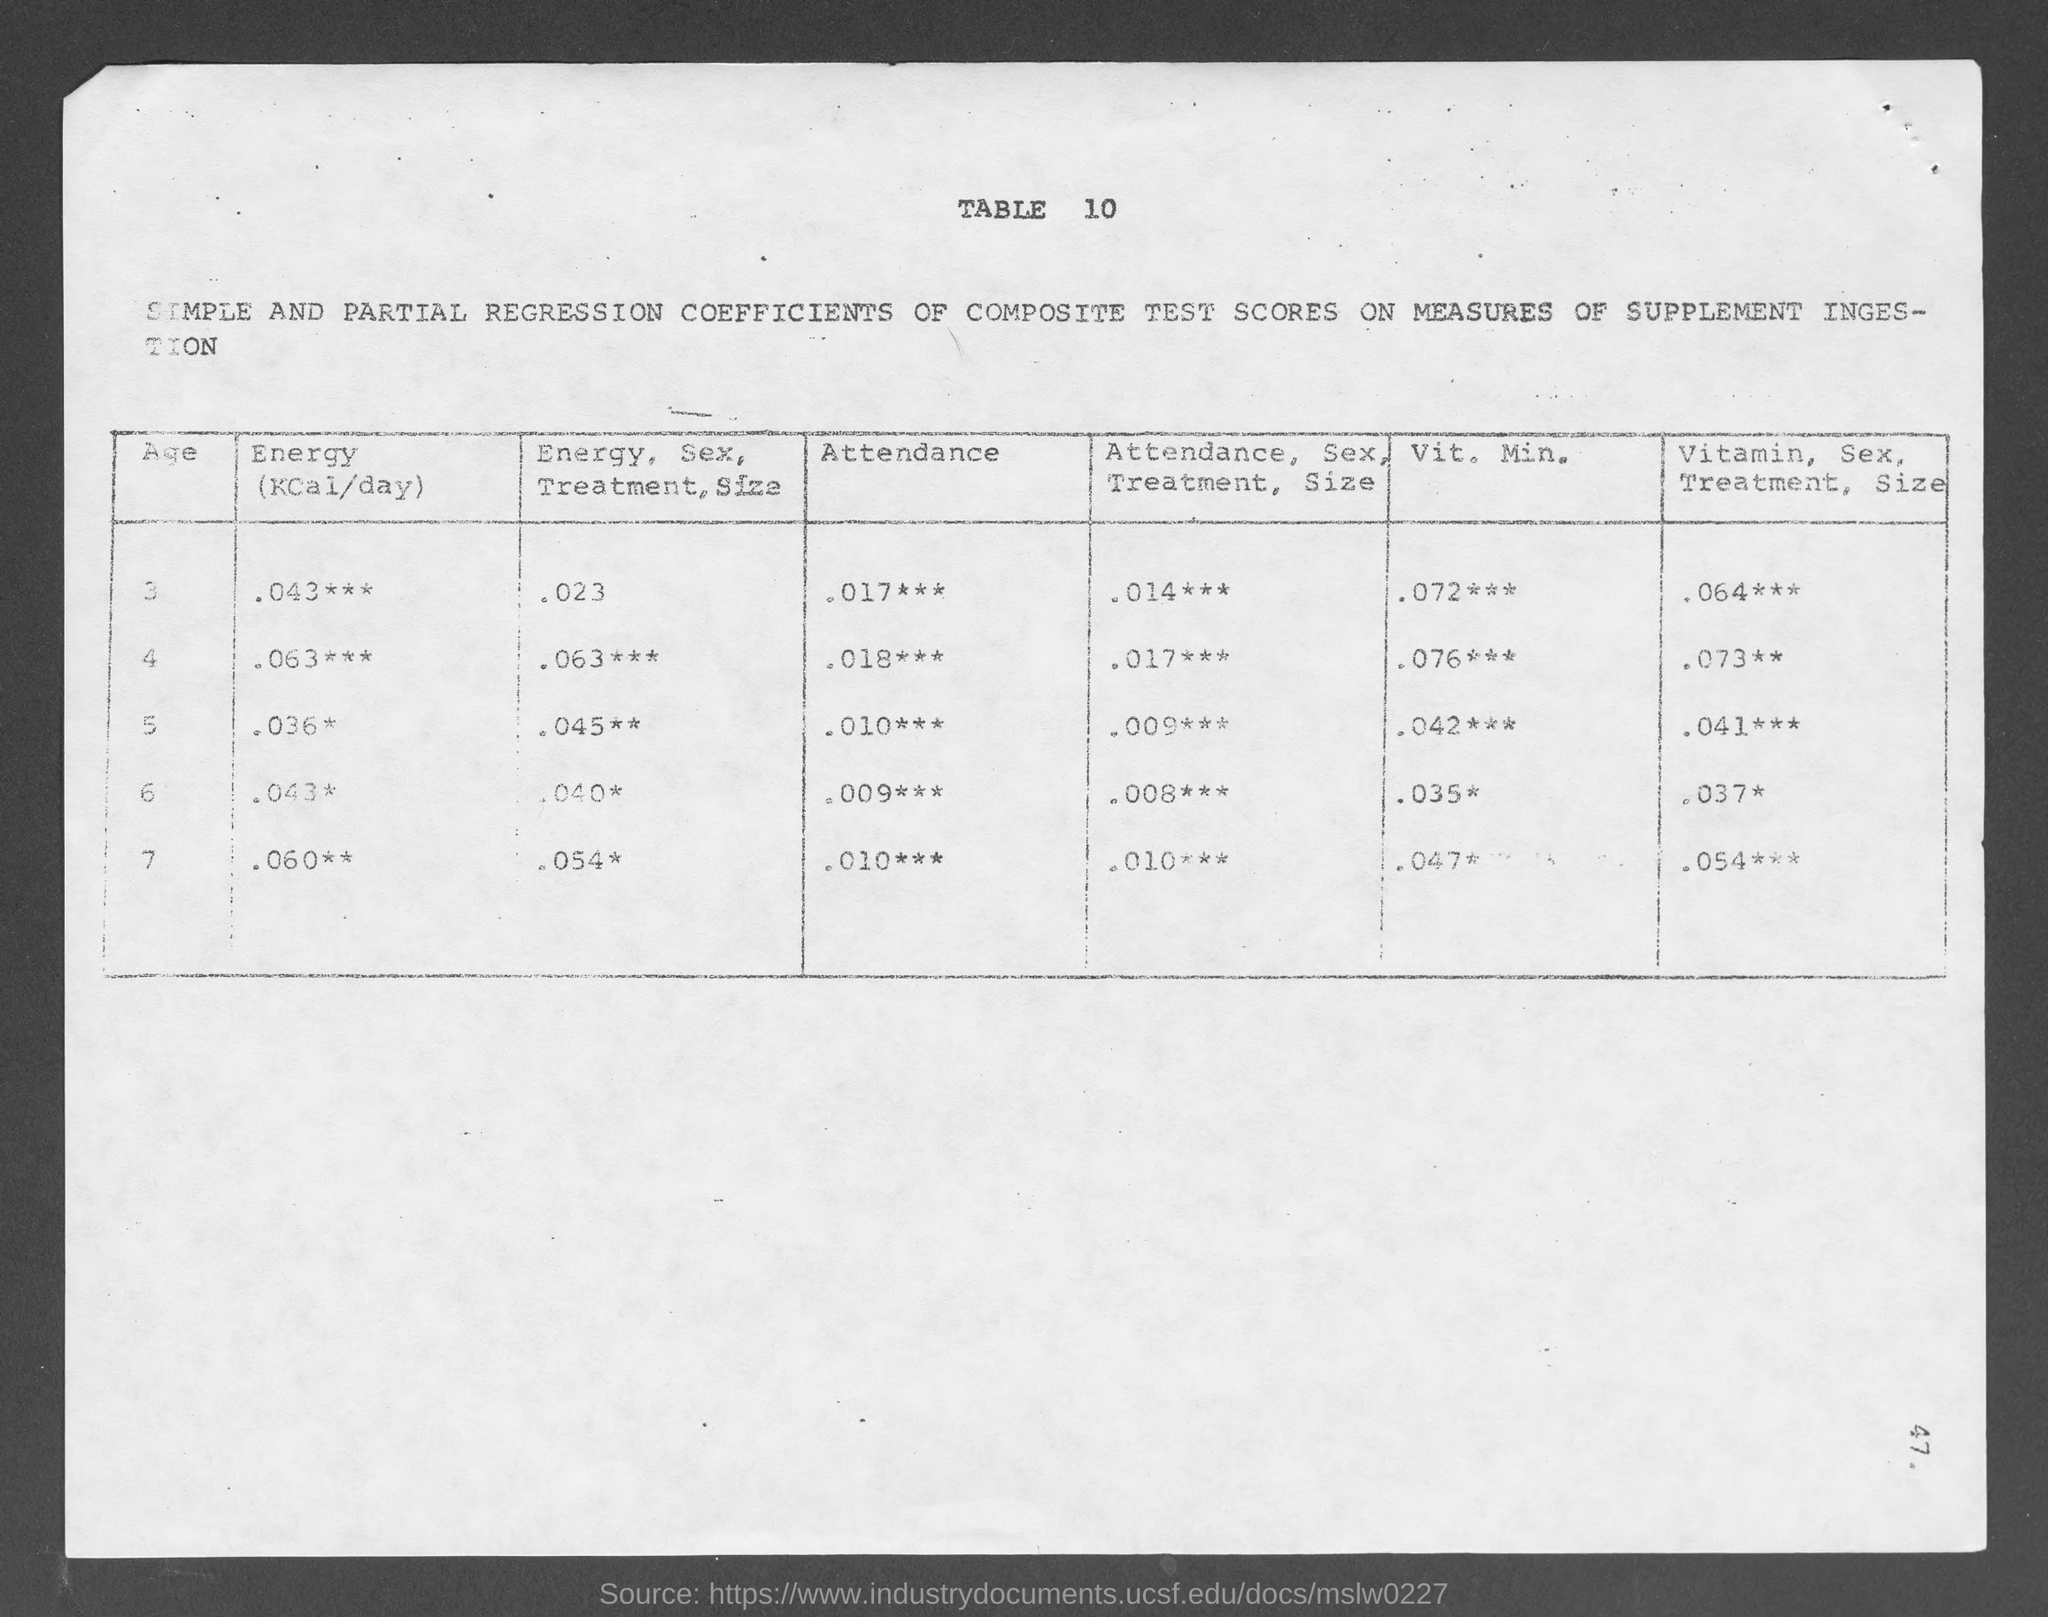what is the table no.?
 10 